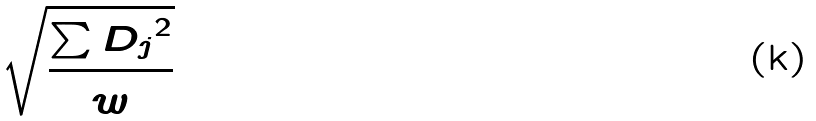Convert formula to latex. <formula><loc_0><loc_0><loc_500><loc_500>\sqrt { \frac { \sum { D _ { j } } ^ { 2 } } { w } }</formula> 